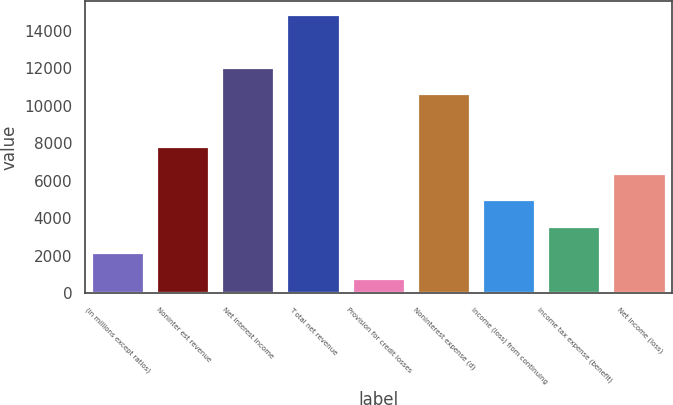Convert chart. <chart><loc_0><loc_0><loc_500><loc_500><bar_chart><fcel>(in millions except ratios)<fcel>Noninter est revenue<fcel>Net interest income<fcel>T otal net revenue<fcel>Provision for credit losses<fcel>Noninterest expense (d)<fcel>Income (loss) from continuing<fcel>Income tax expense (benefit)<fcel>Net income (loss)<nl><fcel>2134.6<fcel>7777<fcel>12008.8<fcel>14830<fcel>724<fcel>10598.2<fcel>4955.8<fcel>3545.2<fcel>6366.4<nl></chart> 